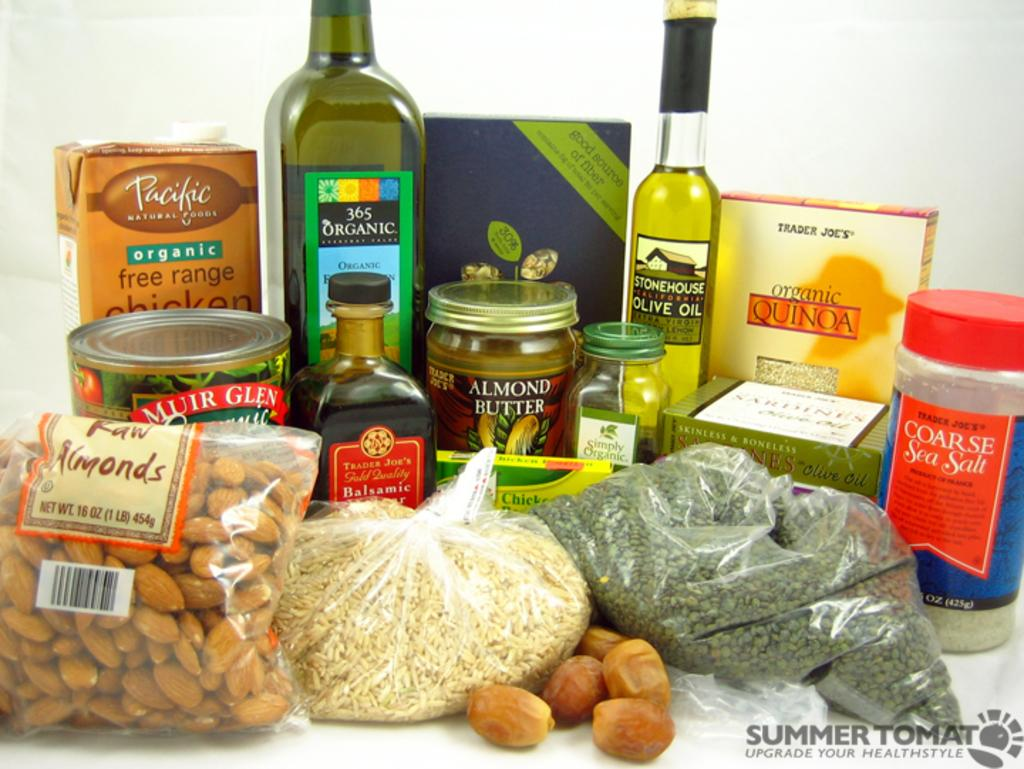<image>
Share a concise interpretation of the image provided. A box of organic quinoa sits with other grocery items. 